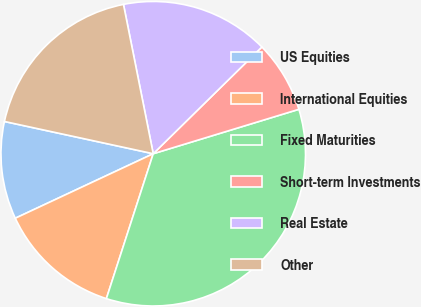<chart> <loc_0><loc_0><loc_500><loc_500><pie_chart><fcel>US Equities<fcel>International Equities<fcel>Fixed Maturities<fcel>Short-term Investments<fcel>Real Estate<fcel>Other<nl><fcel>10.36%<fcel>13.06%<fcel>34.69%<fcel>7.65%<fcel>15.77%<fcel>18.47%<nl></chart> 